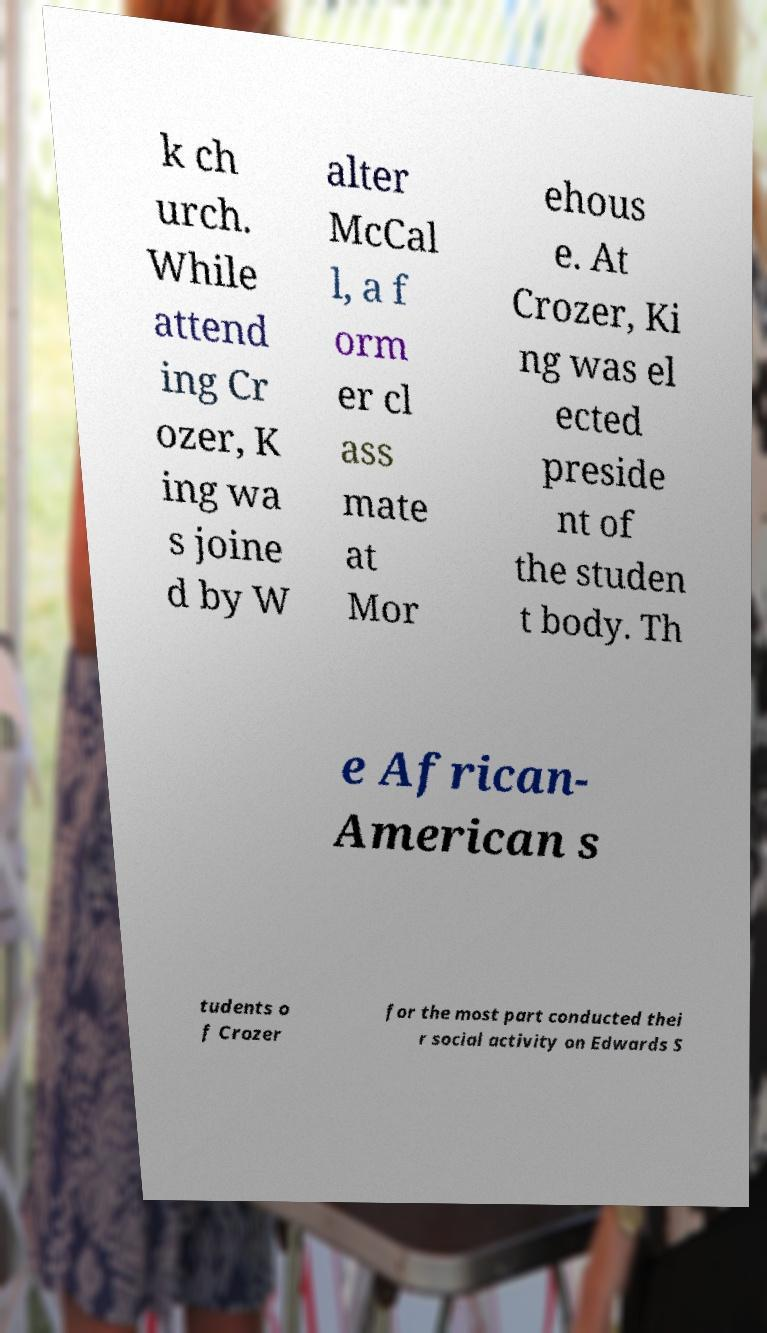I need the written content from this picture converted into text. Can you do that? k ch urch. While attend ing Cr ozer, K ing wa s joine d by W alter McCal l, a f orm er cl ass mate at Mor ehous e. At Crozer, Ki ng was el ected preside nt of the studen t body. Th e African- American s tudents o f Crozer for the most part conducted thei r social activity on Edwards S 